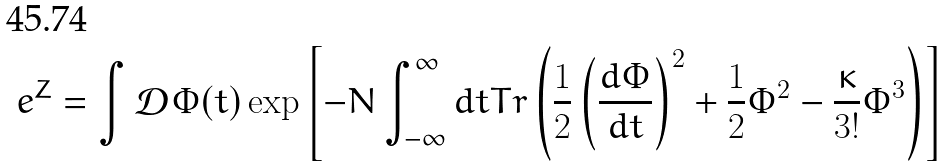Convert formula to latex. <formula><loc_0><loc_0><loc_500><loc_500>e ^ { Z } = \int \mathcal { D } \Phi ( t ) \exp \left [ - N \int _ { - \infty } ^ { \infty } d t T r \left ( \frac { 1 } { 2 } \left ( \frac { d \Phi } { d t } \right ) ^ { 2 } + \frac { 1 } { 2 } \Phi ^ { 2 } - \frac { \kappa } { 3 ! } \Phi ^ { 3 } \right ) \right ]</formula> 